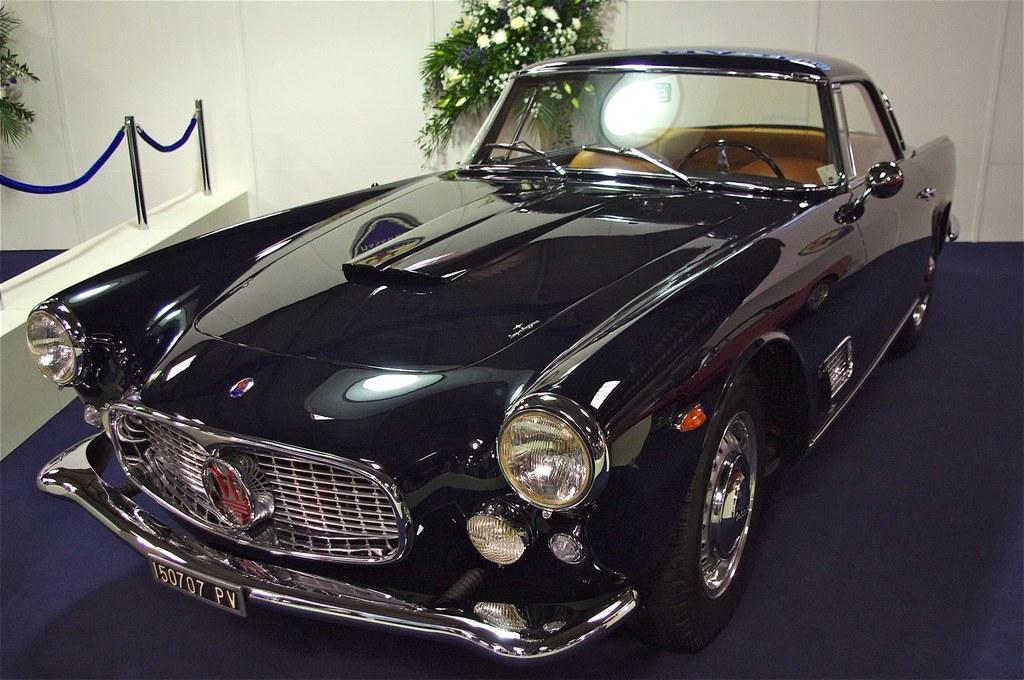Can you describe this image briefly? In this image I can see the vehicle which is in black color. To the left I can see the poles and the ribbon. In the background I can see the plants and the white wall. 